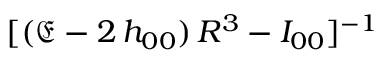Convert formula to latex. <formula><loc_0><loc_0><loc_500><loc_500>[ ( \mathfrak { E } - 2 \, h _ { 0 0 } ) \, R ^ { 3 } - I _ { 0 0 } ] ^ { - 1 }</formula> 